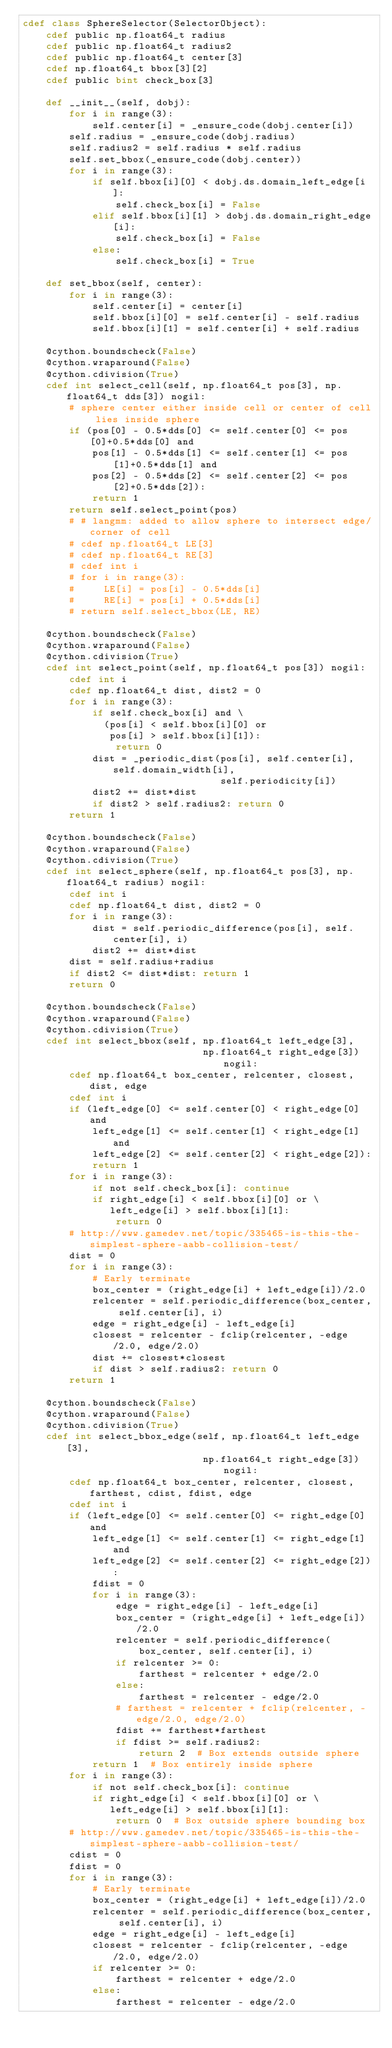<code> <loc_0><loc_0><loc_500><loc_500><_Cython_>cdef class SphereSelector(SelectorObject):
    cdef public np.float64_t radius
    cdef public np.float64_t radius2
    cdef public np.float64_t center[3]
    cdef np.float64_t bbox[3][2]
    cdef public bint check_box[3]

    def __init__(self, dobj):
        for i in range(3):
            self.center[i] = _ensure_code(dobj.center[i])
        self.radius = _ensure_code(dobj.radius)
        self.radius2 = self.radius * self.radius
        self.set_bbox(_ensure_code(dobj.center))
        for i in range(3):
            if self.bbox[i][0] < dobj.ds.domain_left_edge[i]:
                self.check_box[i] = False
            elif self.bbox[i][1] > dobj.ds.domain_right_edge[i]:
                self.check_box[i] = False
            else:
                self.check_box[i] = True

    def set_bbox(self, center):
        for i in range(3):
            self.center[i] = center[i]
            self.bbox[i][0] = self.center[i] - self.radius
            self.bbox[i][1] = self.center[i] + self.radius

    @cython.boundscheck(False)
    @cython.wraparound(False)
    @cython.cdivision(True)
    cdef int select_cell(self, np.float64_t pos[3], np.float64_t dds[3]) nogil:
        # sphere center either inside cell or center of cell lies inside sphere
        if (pos[0] - 0.5*dds[0] <= self.center[0] <= pos[0]+0.5*dds[0] and
            pos[1] - 0.5*dds[1] <= self.center[1] <= pos[1]+0.5*dds[1] and
            pos[2] - 0.5*dds[2] <= self.center[2] <= pos[2]+0.5*dds[2]):
            return 1
        return self.select_point(pos)
        # # langmm: added to allow sphere to intersect edge/corner of cell
        # cdef np.float64_t LE[3]
        # cdef np.float64_t RE[3]
        # cdef int i
        # for i in range(3):
        #     LE[i] = pos[i] - 0.5*dds[i]
        #     RE[i] = pos[i] + 0.5*dds[i]
        # return self.select_bbox(LE, RE)

    @cython.boundscheck(False)
    @cython.wraparound(False)
    @cython.cdivision(True)
    cdef int select_point(self, np.float64_t pos[3]) nogil:
        cdef int i
        cdef np.float64_t dist, dist2 = 0
        for i in range(3):
            if self.check_box[i] and \
              (pos[i] < self.bbox[i][0] or
               pos[i] > self.bbox[i][1]):
                return 0
            dist = _periodic_dist(pos[i], self.center[i], self.domain_width[i],
                                  self.periodicity[i])
            dist2 += dist*dist
            if dist2 > self.radius2: return 0
        return 1

    @cython.boundscheck(False)
    @cython.wraparound(False)
    @cython.cdivision(True)
    cdef int select_sphere(self, np.float64_t pos[3], np.float64_t radius) nogil:
        cdef int i
        cdef np.float64_t dist, dist2 = 0
        for i in range(3):
            dist = self.periodic_difference(pos[i], self.center[i], i)
            dist2 += dist*dist
        dist = self.radius+radius
        if dist2 <= dist*dist: return 1
        return 0

    @cython.boundscheck(False)
    @cython.wraparound(False)
    @cython.cdivision(True)
    cdef int select_bbox(self, np.float64_t left_edge[3],
                               np.float64_t right_edge[3]) nogil:
        cdef np.float64_t box_center, relcenter, closest, dist, edge
        cdef int i
        if (left_edge[0] <= self.center[0] < right_edge[0] and
            left_edge[1] <= self.center[1] < right_edge[1] and
            left_edge[2] <= self.center[2] < right_edge[2]):
            return 1
        for i in range(3):
            if not self.check_box[i]: continue
            if right_edge[i] < self.bbox[i][0] or \
               left_edge[i] > self.bbox[i][1]:
                return 0
        # http://www.gamedev.net/topic/335465-is-this-the-simplest-sphere-aabb-collision-test/
        dist = 0
        for i in range(3):
            # Early terminate
            box_center = (right_edge[i] + left_edge[i])/2.0
            relcenter = self.periodic_difference(box_center, self.center[i], i)
            edge = right_edge[i] - left_edge[i]
            closest = relcenter - fclip(relcenter, -edge/2.0, edge/2.0)
            dist += closest*closest
            if dist > self.radius2: return 0
        return 1

    @cython.boundscheck(False)
    @cython.wraparound(False)
    @cython.cdivision(True)
    cdef int select_bbox_edge(self, np.float64_t left_edge[3],
                               np.float64_t right_edge[3]) nogil:
        cdef np.float64_t box_center, relcenter, closest, farthest, cdist, fdist, edge
        cdef int i
        if (left_edge[0] <= self.center[0] <= right_edge[0] and
            left_edge[1] <= self.center[1] <= right_edge[1] and
            left_edge[2] <= self.center[2] <= right_edge[2]):
            fdist = 0
            for i in range(3):
                edge = right_edge[i] - left_edge[i]
                box_center = (right_edge[i] + left_edge[i])/2.0
                relcenter = self.periodic_difference(
                    box_center, self.center[i], i)
                if relcenter >= 0:
                    farthest = relcenter + edge/2.0
                else:
                    farthest = relcenter - edge/2.0
                # farthest = relcenter + fclip(relcenter, -edge/2.0, edge/2.0)
                fdist += farthest*farthest
                if fdist >= self.radius2:
                    return 2  # Box extends outside sphere
            return 1  # Box entirely inside sphere
        for i in range(3):
            if not self.check_box[i]: continue
            if right_edge[i] < self.bbox[i][0] or \
               left_edge[i] > self.bbox[i][1]:
                return 0  # Box outside sphere bounding box
        # http://www.gamedev.net/topic/335465-is-this-the-simplest-sphere-aabb-collision-test/
        cdist = 0
        fdist = 0
        for i in range(3):
            # Early terminate
            box_center = (right_edge[i] + left_edge[i])/2.0
            relcenter = self.periodic_difference(box_center, self.center[i], i)
            edge = right_edge[i] - left_edge[i]
            closest = relcenter - fclip(relcenter, -edge/2.0, edge/2.0)
            if relcenter >= 0:
                farthest = relcenter + edge/2.0
            else:
                farthest = relcenter - edge/2.0</code> 